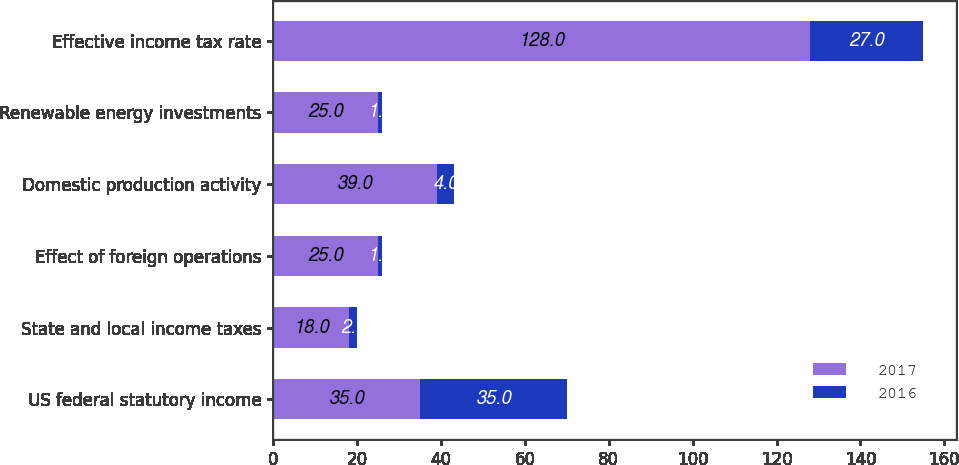<chart> <loc_0><loc_0><loc_500><loc_500><stacked_bar_chart><ecel><fcel>US federal statutory income<fcel>State and local income taxes<fcel>Effect of foreign operations<fcel>Domestic production activity<fcel>Renewable energy investments<fcel>Effective income tax rate<nl><fcel>2017<fcel>35<fcel>18<fcel>25<fcel>39<fcel>25<fcel>128<nl><fcel>2016<fcel>35<fcel>2<fcel>1<fcel>4<fcel>1<fcel>27<nl></chart> 